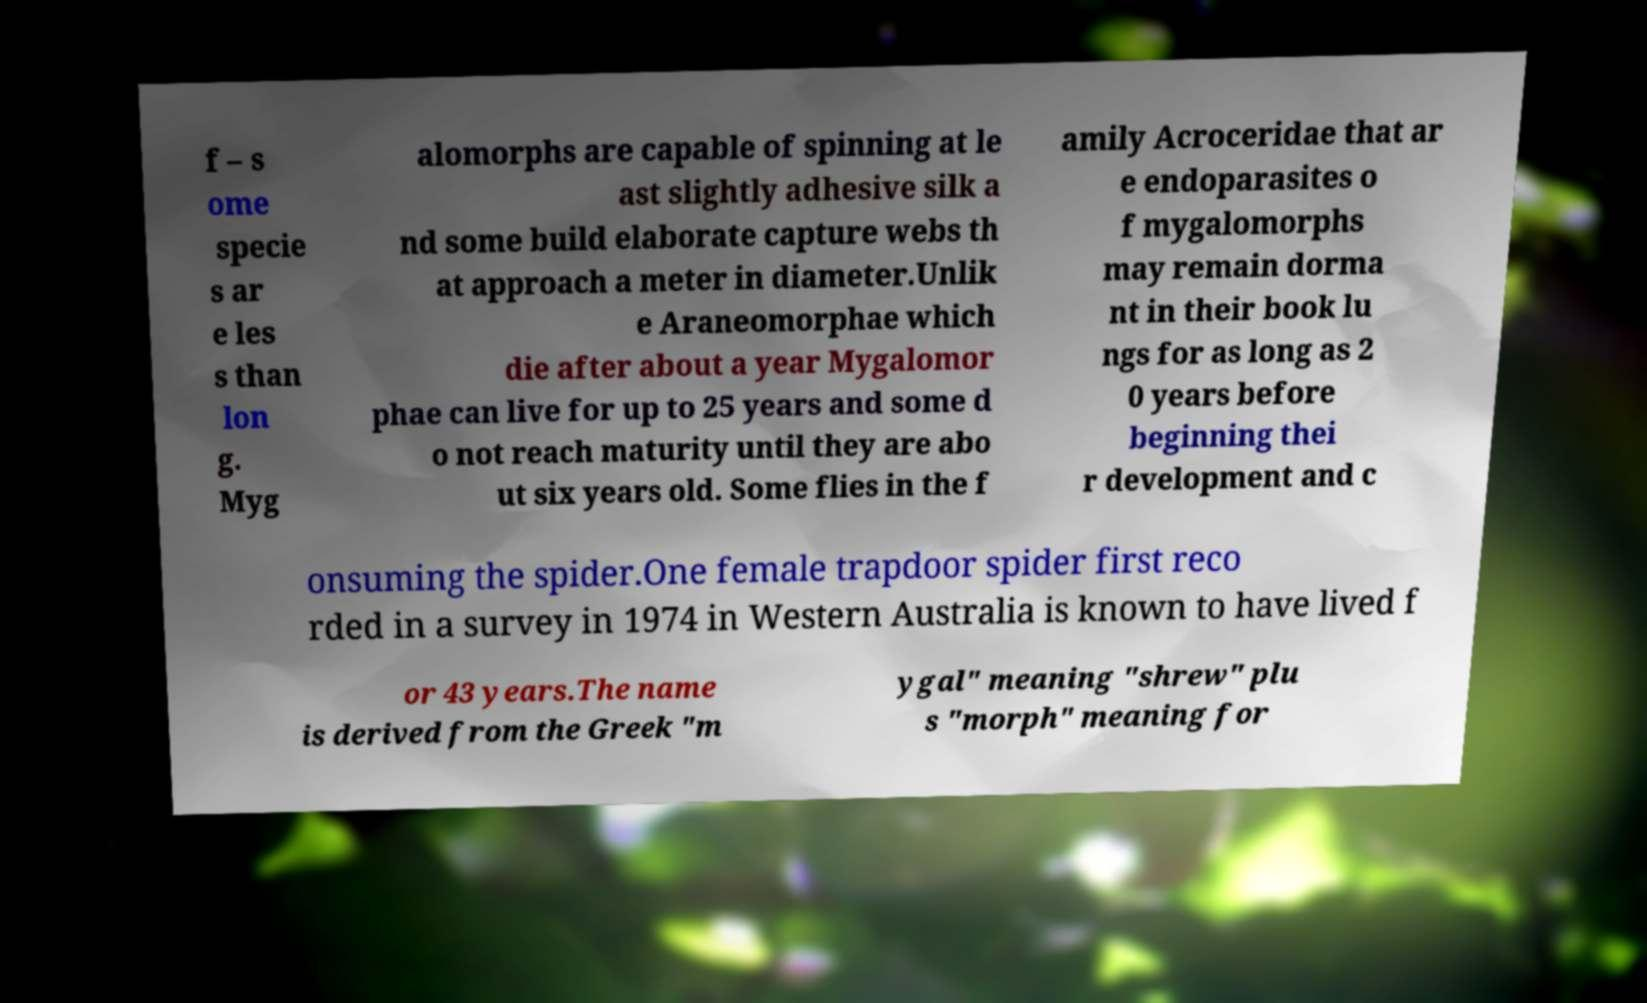Please read and relay the text visible in this image. What does it say? f – s ome specie s ar e les s than lon g. Myg alomorphs are capable of spinning at le ast slightly adhesive silk a nd some build elaborate capture webs th at approach a meter in diameter.Unlik e Araneomorphae which die after about a year Mygalomor phae can live for up to 25 years and some d o not reach maturity until they are abo ut six years old. Some flies in the f amily Acroceridae that ar e endoparasites o f mygalomorphs may remain dorma nt in their book lu ngs for as long as 2 0 years before beginning thei r development and c onsuming the spider.One female trapdoor spider first reco rded in a survey in 1974 in Western Australia is known to have lived f or 43 years.The name is derived from the Greek "m ygal" meaning "shrew" plu s "morph" meaning for 